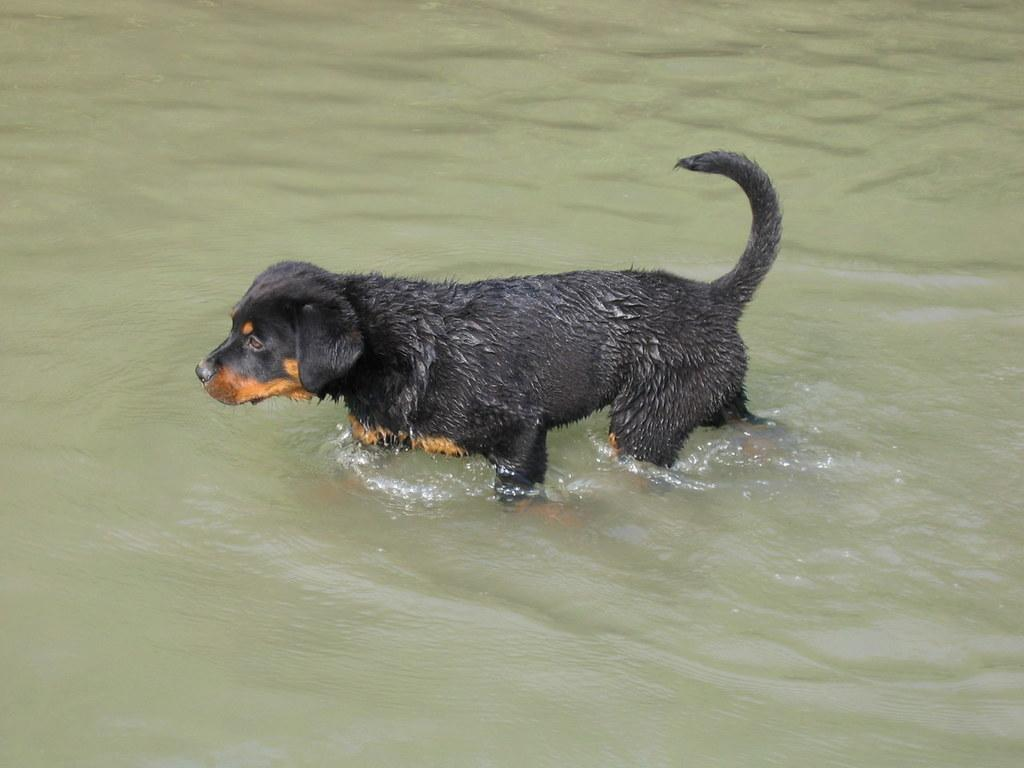What animal is present in the image? There is a dog in the image. What colors can be seen on the dog? The dog is black and brown in color. Where is the dog located in the image? The dog is in the water. What is the dog pointing at in the image? There is no indication that the dog is pointing at anything in the image. 